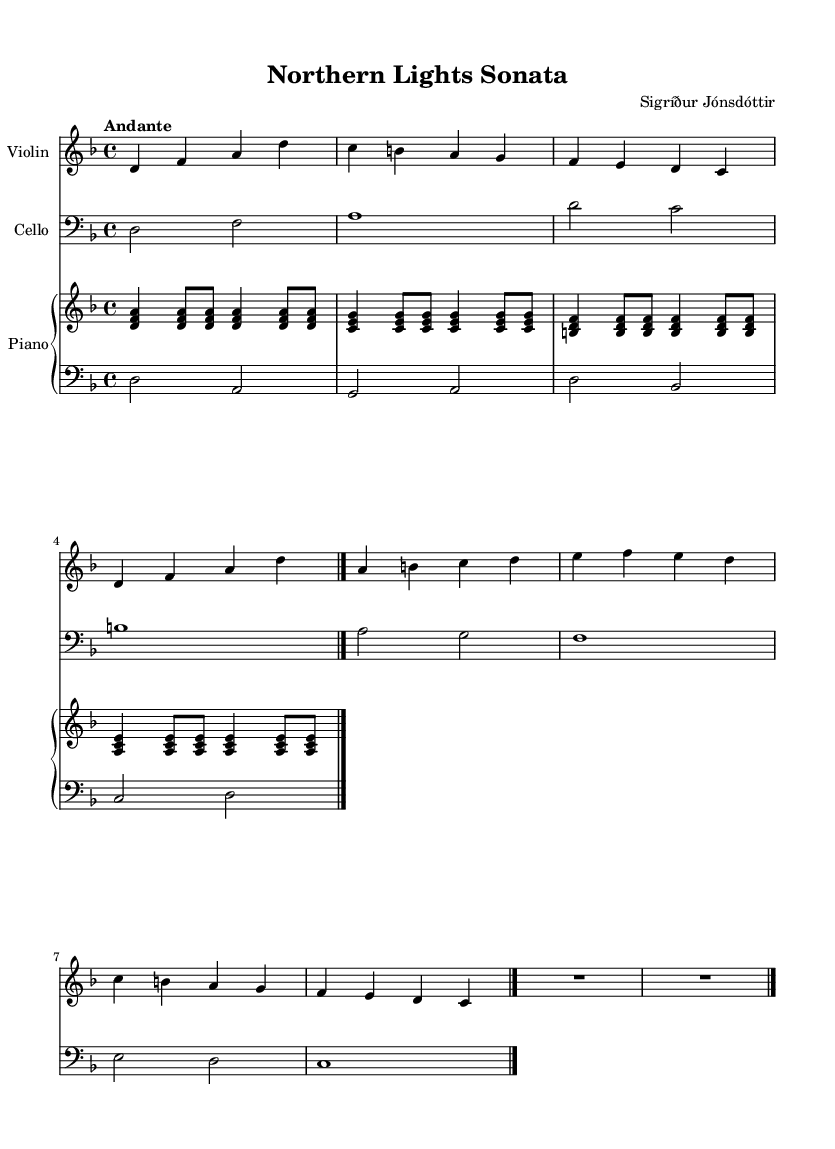What is the key signature of this music? The key signature is two flats, indicating it is in the key of D minor. This can be identified by looking at the key signature at the beginning of the staff.
Answer: D minor What is the time signature of this piece? The time signature is 4/4, which is indicated at the beginning of the score right after the key signature. This means there are four beats in each measure, and the quarter note gets one beat.
Answer: 4/4 What is the indicated tempo for this composition? The tempo marking states "Andante," which is a term that specifies the piece should be played at a moderately slow pace. This can be found in the tempo marking provided at the start of the music.
Answer: Andante How many measures are present in the violin part? There are eight measures in the violin part. This can be counted by looking at the vertical lines (bar lines) separating the music into sections within the staff.
Answer: 8 In what clef is the cello music written? The cello music is written in the bass clef, which is identified by the signature symbol at the beginning of the cello staff. This is standard for lower-pitched instruments.
Answer: Bass clef What is the highest note played in the piano's right hand? The highest note played in the piano's right hand is A. This can be determined by analyzing the notes written on the staff and observing that A is the topmost note played in its section.
Answer: A What is the rhythmic pattern used in the left hand of the piano? The left hand of the piano features a pattern consisting of half note and quarter note rhythms. This can be noted by observing the note lengths written in the score, where some notes appear as half notes (2 beats) and some as quarter notes (1 beat).
Answer: Half and quarter notes 